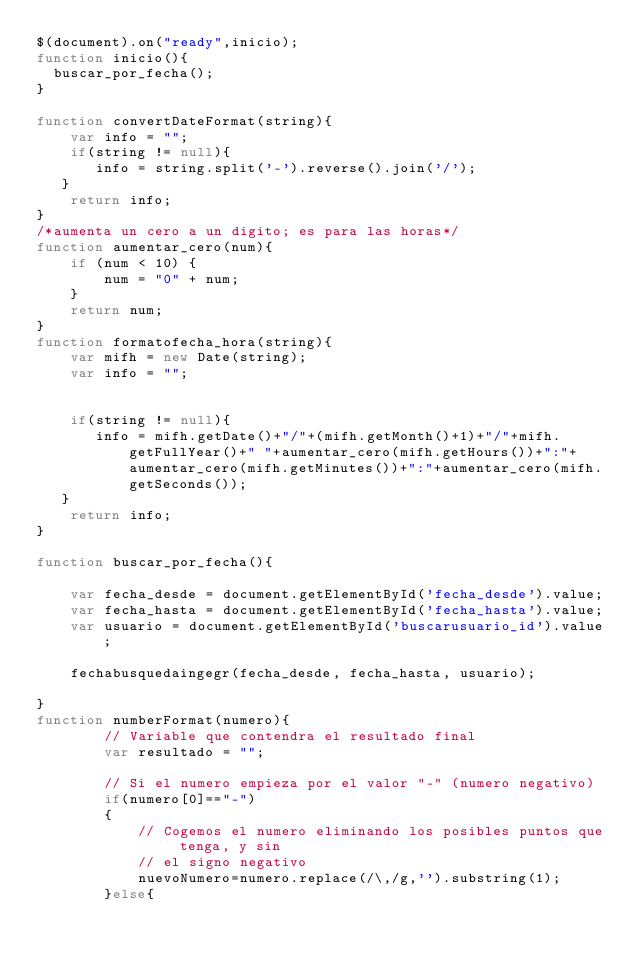<code> <loc_0><loc_0><loc_500><loc_500><_JavaScript_>$(document).on("ready",inicio);
function inicio(){
  buscar_por_fecha(); 
}

function convertDateFormat(string){
    var info = "";
    if(string != null){
       info = string.split('-').reverse().join('/');
   }
    return info;
}
/*aumenta un cero a un digito; es para las horas*/
function aumentar_cero(num){
    if (num < 10) {
        num = "0" + num;
    }
    return num;
}
function formatofecha_hora(string){
    var mifh = new Date(string);
    var info = "";
    

    if(string != null){
       info = mifh.getDate()+"/"+(mifh.getMonth()+1)+"/"+mifh.getFullYear()+" "+aumentar_cero(mifh.getHours())+":"+aumentar_cero(mifh.getMinutes())+":"+aumentar_cero(mifh.getSeconds());
   }
    return info;
}
    
function buscar_por_fecha(){

    var fecha_desde = document.getElementById('fecha_desde').value;
    var fecha_hasta = document.getElementById('fecha_hasta').value;
    var usuario = document.getElementById('buscarusuario_id').value;
    
    fechabusquedaingegr(fecha_desde, fecha_hasta, usuario);

}
function numberFormat(numero){
        // Variable que contendra el resultado final
        var resultado = "";
 
        // Si el numero empieza por el valor "-" (numero negativo)
        if(numero[0]=="-")
        {
            // Cogemos el numero eliminando los posibles puntos que tenga, y sin
            // el signo negativo
            nuevoNumero=numero.replace(/\,/g,'').substring(1);
        }else{</code> 